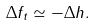Convert formula to latex. <formula><loc_0><loc_0><loc_500><loc_500>\Delta f _ { t } \simeq - \Delta h .</formula> 